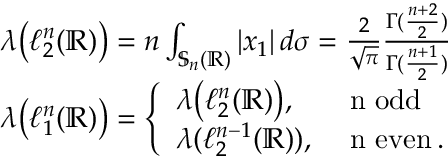Convert formula to latex. <formula><loc_0><loc_0><loc_500><loc_500>\begin{array} { r l } & { \lambda \left ( \ell _ { 2 } ^ { n } ( \mathbb { R } ) \right ) = n \int _ { \mathbb { S } _ { n } ( \mathbb { R } ) } | x _ { 1 } | \, d \sigma = \frac { 2 } { \sqrt { \pi } } \frac { \Gamma ( \frac { n + 2 } { 2 } ) } { \Gamma ( \frac { n + 1 } { 2 } ) } } \\ & { \lambda \left ( \ell _ { 1 } ^ { n } ( \mathbb { R } ) \right ) = \left \{ \begin{array} { l l } { \lambda \left ( \ell _ { 2 } ^ { n } ( \mathbb { R } ) \right ) , } & { n o d d } \\ { \lambda ( \ell _ { 2 } ^ { n - 1 } ( \mathbb { R } ) ) , } & { n e v e n \, . } \end{array} } \end{array}</formula> 